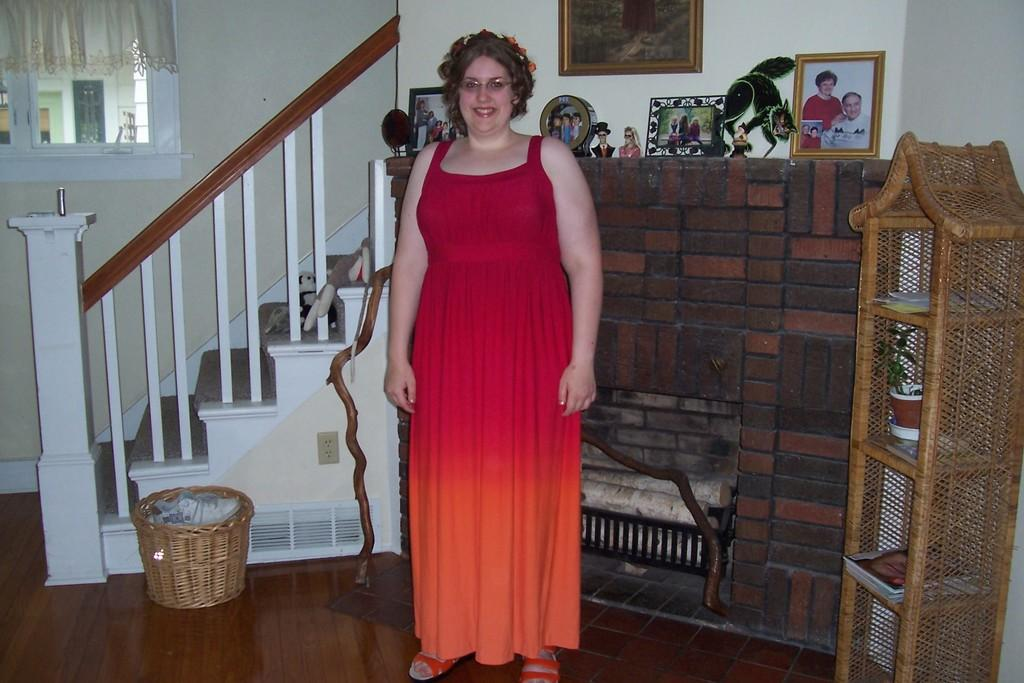What is the main subject of the image? There is a woman standing in the center of the image. What is the woman's expression in the image? The woman is smiling in the image. What can be seen in the background of the image? There is a wall, a railing, a staircase, photo frames, and a few other objects in the background of the image. What type of stomach ache is the woman experiencing in the image? There is no indication in the image that the woman is experiencing any stomach ache. What is the zephyr's role in the image? There is no zephyr present in the image, as it is a mythological term for a gentle breeze and not a physical object or entity. 